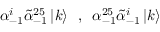Convert formula to latex. <formula><loc_0><loc_0><loc_500><loc_500>\alpha _ { - 1 } ^ { i } \tilde { \alpha } _ { - 1 } ^ { 2 5 } \left | k \right > \, , \, \alpha _ { - 1 } ^ { 2 5 } \tilde { \alpha } _ { - 1 } ^ { i } \left | k \right ></formula> 